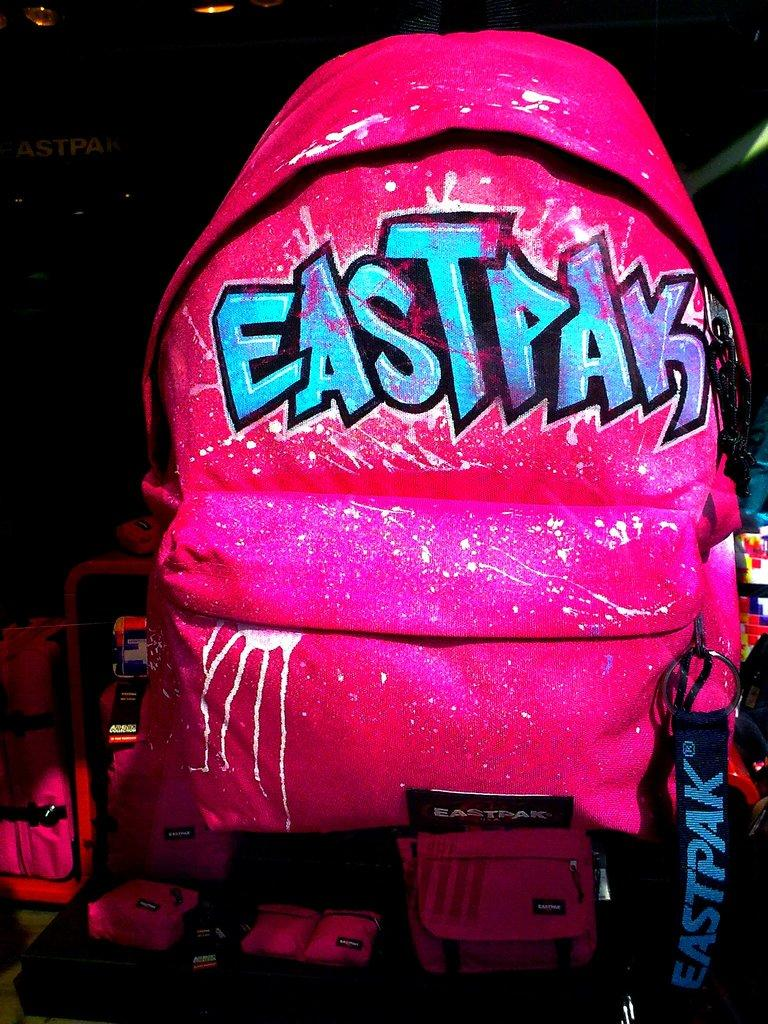What object is present in the image? There is a bag in the image. What brand is the bag? The word "EastPak" is written on the bag. What type of market is being held on this particular day in the image? There is no market or day mentioned in the image; it only features a bag with the word "EastPak" written on it. 